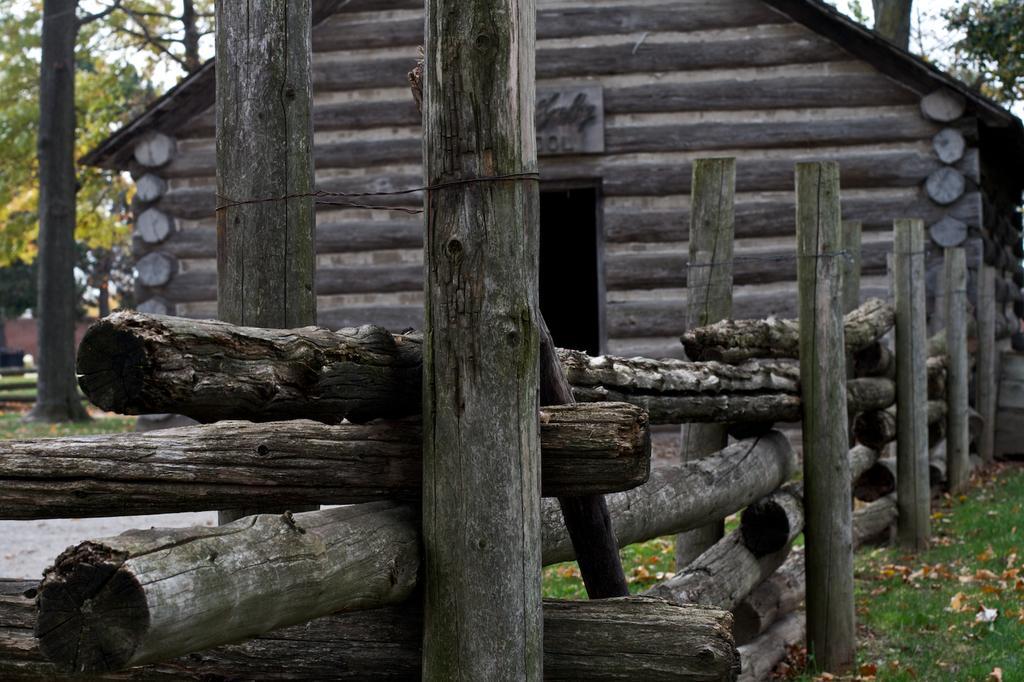In one or two sentences, can you explain what this image depicts? In the center of the image there is a wooden fence, poles, grass and dry leaves. In the background, we can see the sky, clouds, trees, one bench, one house, sign board and a few other objects. 